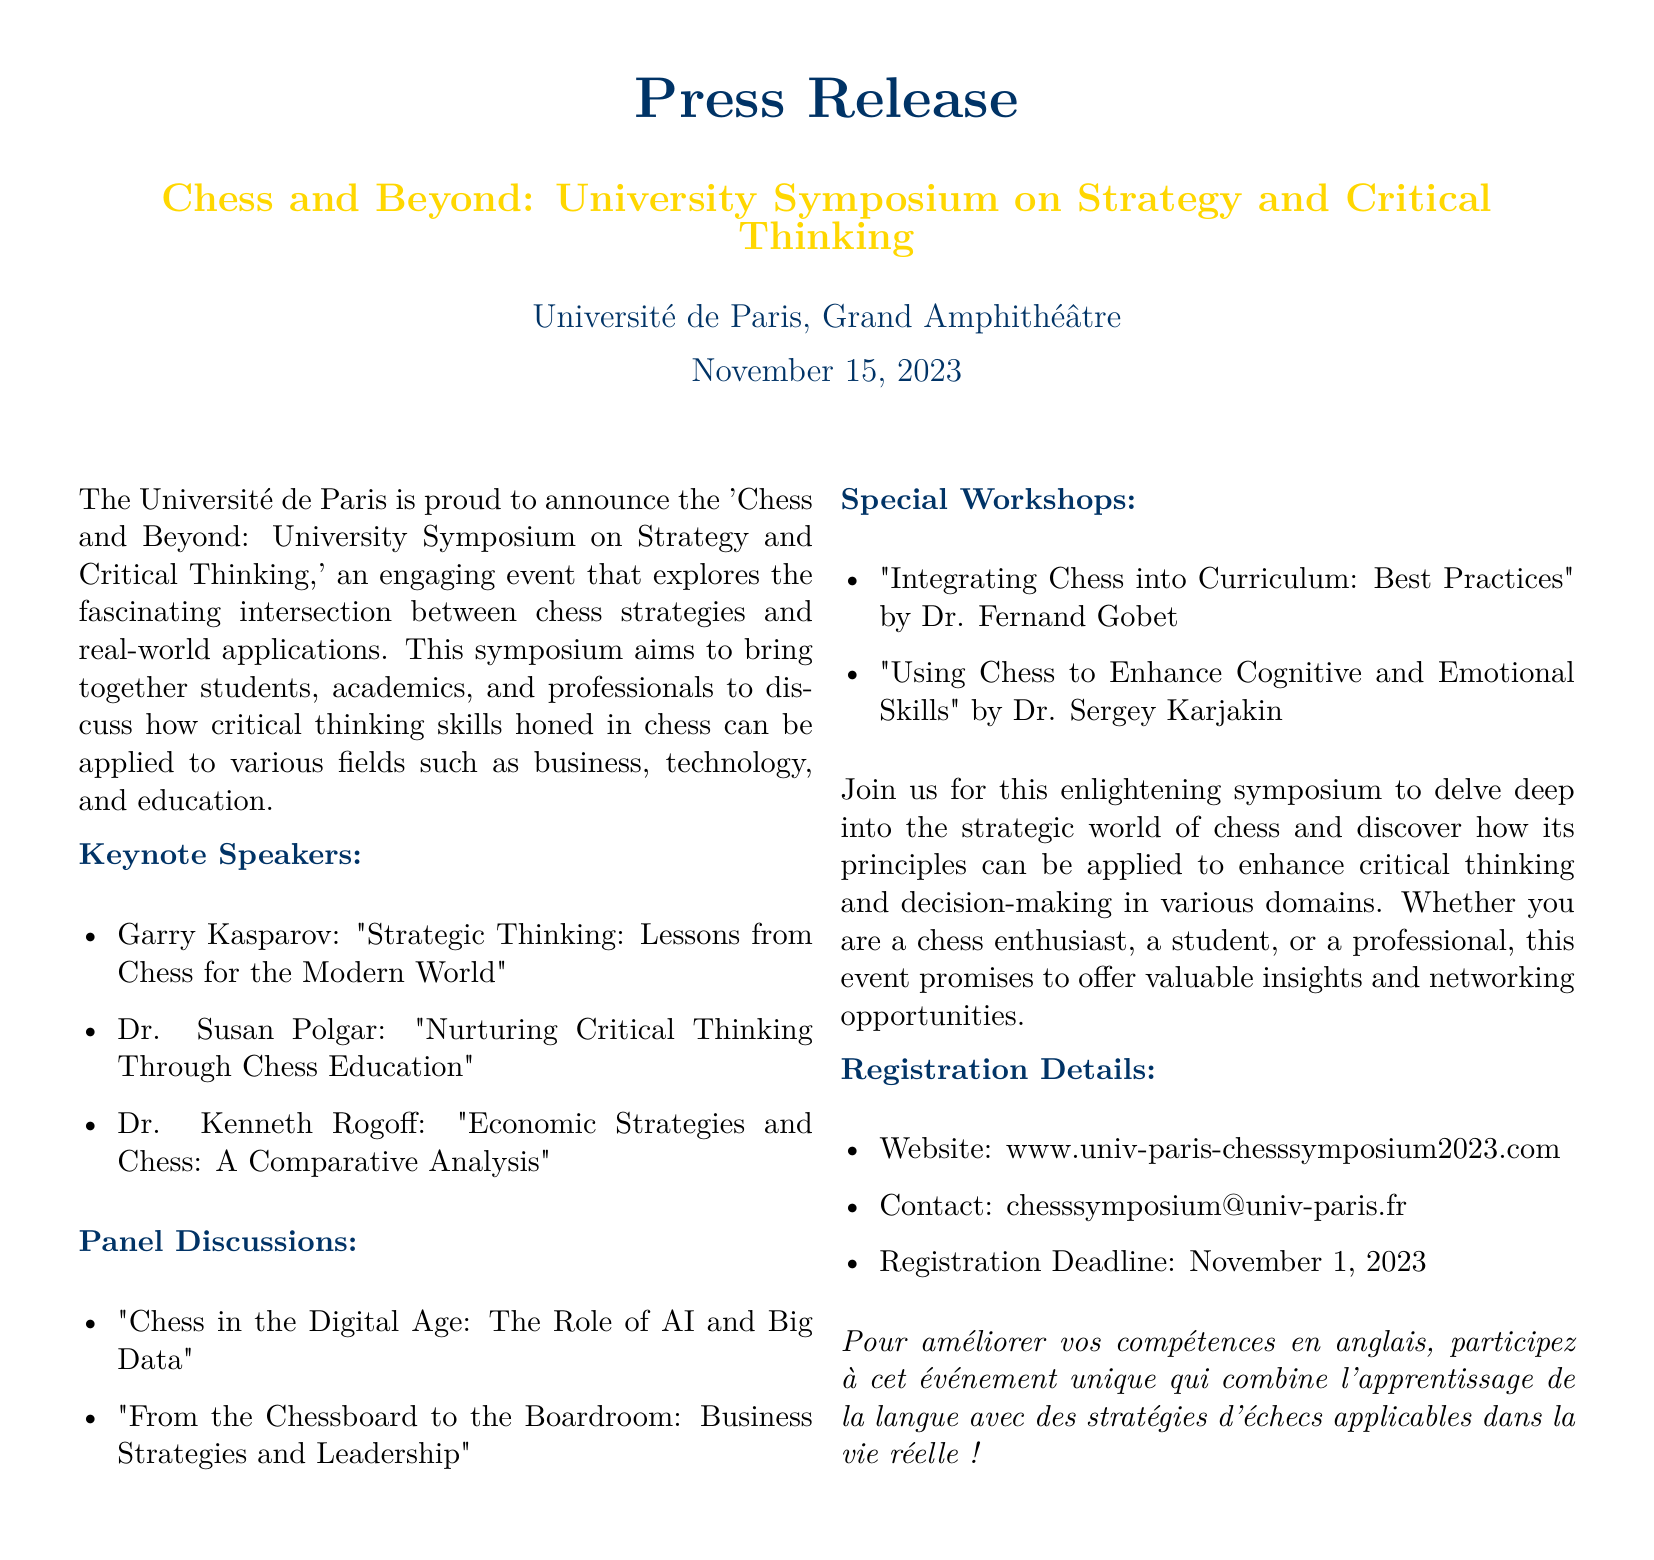What is the name of the symposium? The name of the symposium is clearly stated in the title of the press release.
Answer: Chess and Beyond: University Symposium on Strategy and Critical Thinking What is the date of the event? The press release specifies the date prominently under the title.
Answer: November 15, 2023 Who is one of the keynote speakers? The list of keynote speakers includes notable figures in chess; you can find their names in the specified section.
Answer: Garry Kasparov What is the registration deadline? The registration deadline is mentioned towards the end of the document under registration details.
Answer: November 1, 2023 What is one topic of the panel discussions? The document lists topics for panel discussions, which can be found in a designated section.
Answer: Chess in the Digital Age: The Role of AI and Big Data What university is hosting the symposium? The hosting institution is mentioned at the beginning of the press release.
Answer: Université de Paris What kind of workshops will be offered? The types of workshops are outlined in a specific section of the document.
Answer: Special Workshops How can participants register for the event? The registration method is specified in the document, including a website link.
Answer: www.univ-paris-chesssymposium2023.com What is the main theme of the symposium? The introductory paragraph describes the theme of the symposium focusing on chess and real-world applications.
Answer: Applications of chess strategies to real-world scenarios 